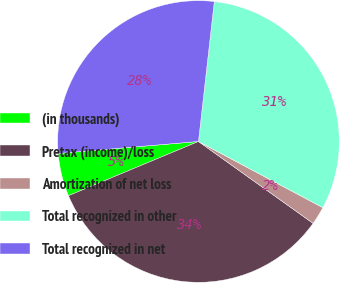Convert chart to OTSL. <chart><loc_0><loc_0><loc_500><loc_500><pie_chart><fcel>(in thousands)<fcel>Pretax (income)/loss<fcel>Amortization of net loss<fcel>Total recognized in other<fcel>Total recognized in net<nl><fcel>4.93%<fcel>33.84%<fcel>2.09%<fcel>30.99%<fcel>28.15%<nl></chart> 